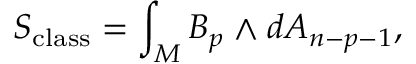Convert formula to latex. <formula><loc_0><loc_0><loc_500><loc_500>S _ { c l a s s } = \int _ { M } B _ { p } \wedge d A _ { n - p - 1 } ,</formula> 